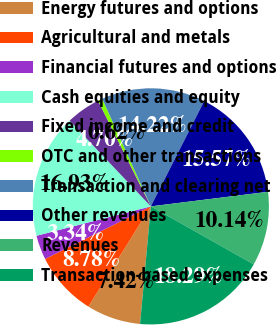<chart> <loc_0><loc_0><loc_500><loc_500><pie_chart><fcel>Energy futures and options<fcel>Agricultural and metals<fcel>Financial futures and options<fcel>Cash equities and equity<fcel>Fixed income and credit<fcel>OTC and other transactions<fcel>Transaction and clearing net<fcel>Other revenues<fcel>Revenues<fcel>Transaction-based expenses<nl><fcel>7.42%<fcel>8.78%<fcel>3.34%<fcel>16.93%<fcel>4.7%<fcel>0.62%<fcel>14.22%<fcel>15.57%<fcel>10.14%<fcel>18.29%<nl></chart> 